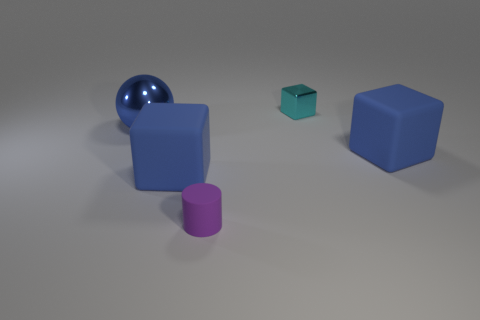What is the shape of the tiny purple rubber object?
Provide a short and direct response. Cylinder. What number of tiny purple rubber things have the same shape as the small cyan thing?
Keep it short and to the point. 0. Are there fewer tiny cyan cubes that are in front of the cyan thing than blue objects in front of the big metal sphere?
Make the answer very short. Yes. There is a small object that is in front of the blue sphere; how many metallic things are on the right side of it?
Provide a succinct answer. 1. Is there a tiny cyan sphere?
Ensure brevity in your answer.  No. Are there any large blue spheres made of the same material as the tiny cyan thing?
Your answer should be compact. Yes. Are there more matte objects that are right of the cyan block than large cubes behind the metal ball?
Provide a short and direct response. Yes. Do the rubber cylinder and the cyan metallic object have the same size?
Your answer should be very brief. Yes. The big matte thing that is behind the large blue cube that is on the left side of the purple cylinder is what color?
Provide a short and direct response. Blue. The rubber cylinder is what color?
Your answer should be very brief. Purple. 